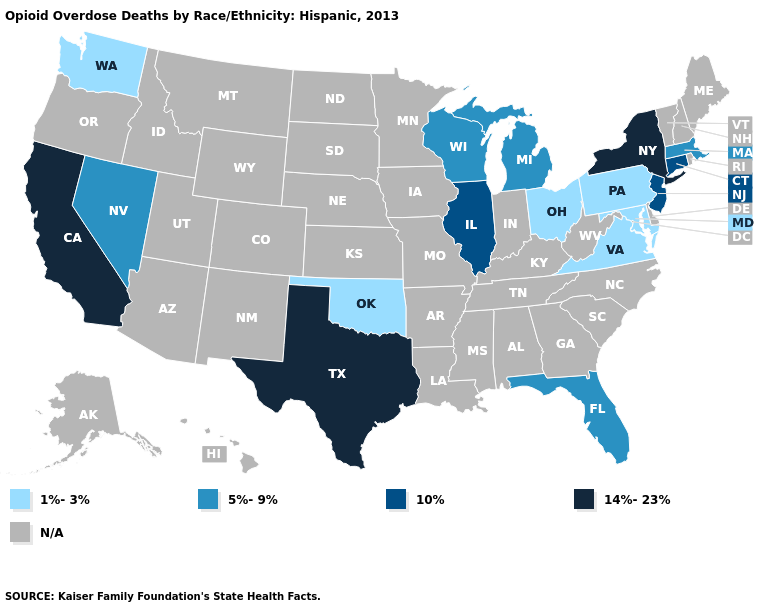What is the value of Wisconsin?
Keep it brief. 5%-9%. Name the states that have a value in the range 5%-9%?
Give a very brief answer. Florida, Massachusetts, Michigan, Nevada, Wisconsin. Name the states that have a value in the range 14%-23%?
Write a very short answer. California, New York, Texas. What is the highest value in the MidWest ?
Answer briefly. 10%. Among the states that border Connecticut , which have the highest value?
Write a very short answer. New York. Name the states that have a value in the range 10%?
Concise answer only. Connecticut, Illinois, New Jersey. What is the value of Missouri?
Keep it brief. N/A. Is the legend a continuous bar?
Concise answer only. No. Name the states that have a value in the range 14%-23%?
Quick response, please. California, New York, Texas. What is the value of Maine?
Quick response, please. N/A. Which states have the lowest value in the West?
Concise answer only. Washington. Name the states that have a value in the range 1%-3%?
Give a very brief answer. Maryland, Ohio, Oklahoma, Pennsylvania, Virginia, Washington. What is the highest value in the Northeast ?
Answer briefly. 14%-23%. What is the highest value in the MidWest ?
Concise answer only. 10%. 